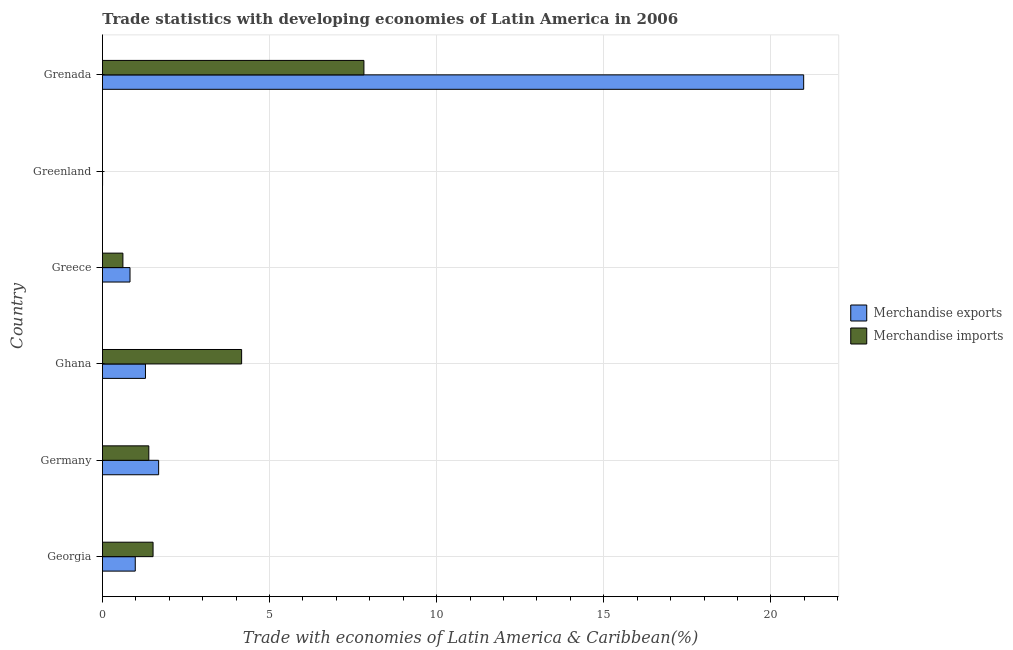How many different coloured bars are there?
Give a very brief answer. 2. How many groups of bars are there?
Make the answer very short. 6. How many bars are there on the 5th tick from the top?
Provide a succinct answer. 2. How many bars are there on the 1st tick from the bottom?
Provide a succinct answer. 2. What is the label of the 4th group of bars from the top?
Give a very brief answer. Ghana. What is the merchandise exports in Greenland?
Your answer should be compact. 0. Across all countries, what is the maximum merchandise imports?
Give a very brief answer. 7.82. Across all countries, what is the minimum merchandise imports?
Offer a terse response. 0. In which country was the merchandise exports maximum?
Ensure brevity in your answer.  Grenada. In which country was the merchandise imports minimum?
Provide a succinct answer. Greenland. What is the total merchandise imports in the graph?
Offer a terse response. 15.5. What is the difference between the merchandise imports in Germany and that in Greenland?
Offer a very short reply. 1.39. What is the difference between the merchandise exports in Grenada and the merchandise imports in Ghana?
Give a very brief answer. 16.82. What is the average merchandise exports per country?
Your answer should be very brief. 4.29. What is the difference between the merchandise exports and merchandise imports in Germany?
Offer a very short reply. 0.29. In how many countries, is the merchandise imports greater than 10 %?
Provide a succinct answer. 0. What is the ratio of the merchandise imports in Georgia to that in Grenada?
Your response must be concise. 0.19. Is the merchandise exports in Germany less than that in Ghana?
Provide a short and direct response. No. Is the difference between the merchandise imports in Georgia and Greenland greater than the difference between the merchandise exports in Georgia and Greenland?
Your response must be concise. Yes. What is the difference between the highest and the second highest merchandise imports?
Offer a terse response. 3.66. What is the difference between the highest and the lowest merchandise imports?
Offer a very short reply. 7.82. In how many countries, is the merchandise exports greater than the average merchandise exports taken over all countries?
Keep it short and to the point. 1. Is the sum of the merchandise imports in Georgia and Grenada greater than the maximum merchandise exports across all countries?
Provide a succinct answer. No. How many bars are there?
Provide a short and direct response. 12. Are all the bars in the graph horizontal?
Your answer should be compact. Yes. What is the difference between two consecutive major ticks on the X-axis?
Keep it short and to the point. 5. Does the graph contain any zero values?
Provide a short and direct response. No. Where does the legend appear in the graph?
Provide a succinct answer. Center right. What is the title of the graph?
Keep it short and to the point. Trade statistics with developing economies of Latin America in 2006. Does "Highest 10% of population" appear as one of the legend labels in the graph?
Make the answer very short. No. What is the label or title of the X-axis?
Make the answer very short. Trade with economies of Latin America & Caribbean(%). What is the Trade with economies of Latin America & Caribbean(%) of Merchandise exports in Georgia?
Provide a succinct answer. 0.98. What is the Trade with economies of Latin America & Caribbean(%) in Merchandise imports in Georgia?
Ensure brevity in your answer.  1.51. What is the Trade with economies of Latin America & Caribbean(%) of Merchandise exports in Germany?
Your answer should be compact. 1.68. What is the Trade with economies of Latin America & Caribbean(%) in Merchandise imports in Germany?
Make the answer very short. 1.39. What is the Trade with economies of Latin America & Caribbean(%) in Merchandise exports in Ghana?
Provide a succinct answer. 1.29. What is the Trade with economies of Latin America & Caribbean(%) of Merchandise imports in Ghana?
Provide a succinct answer. 4.16. What is the Trade with economies of Latin America & Caribbean(%) of Merchandise exports in Greece?
Ensure brevity in your answer.  0.82. What is the Trade with economies of Latin America & Caribbean(%) in Merchandise imports in Greece?
Provide a short and direct response. 0.61. What is the Trade with economies of Latin America & Caribbean(%) in Merchandise exports in Greenland?
Ensure brevity in your answer.  0. What is the Trade with economies of Latin America & Caribbean(%) of Merchandise imports in Greenland?
Make the answer very short. 0. What is the Trade with economies of Latin America & Caribbean(%) in Merchandise exports in Grenada?
Your answer should be compact. 20.98. What is the Trade with economies of Latin America & Caribbean(%) in Merchandise imports in Grenada?
Your answer should be very brief. 7.82. Across all countries, what is the maximum Trade with economies of Latin America & Caribbean(%) of Merchandise exports?
Your response must be concise. 20.98. Across all countries, what is the maximum Trade with economies of Latin America & Caribbean(%) in Merchandise imports?
Your response must be concise. 7.82. Across all countries, what is the minimum Trade with economies of Latin America & Caribbean(%) in Merchandise exports?
Your response must be concise. 0. Across all countries, what is the minimum Trade with economies of Latin America & Caribbean(%) in Merchandise imports?
Offer a very short reply. 0. What is the total Trade with economies of Latin America & Caribbean(%) of Merchandise exports in the graph?
Offer a terse response. 25.76. What is the total Trade with economies of Latin America & Caribbean(%) in Merchandise imports in the graph?
Offer a very short reply. 15.5. What is the difference between the Trade with economies of Latin America & Caribbean(%) of Merchandise exports in Georgia and that in Germany?
Keep it short and to the point. -0.7. What is the difference between the Trade with economies of Latin America & Caribbean(%) in Merchandise imports in Georgia and that in Germany?
Keep it short and to the point. 0.13. What is the difference between the Trade with economies of Latin America & Caribbean(%) of Merchandise exports in Georgia and that in Ghana?
Your answer should be very brief. -0.31. What is the difference between the Trade with economies of Latin America & Caribbean(%) in Merchandise imports in Georgia and that in Ghana?
Ensure brevity in your answer.  -2.65. What is the difference between the Trade with economies of Latin America & Caribbean(%) of Merchandise exports in Georgia and that in Greece?
Ensure brevity in your answer.  0.16. What is the difference between the Trade with economies of Latin America & Caribbean(%) in Merchandise imports in Georgia and that in Greece?
Offer a terse response. 0.9. What is the difference between the Trade with economies of Latin America & Caribbean(%) of Merchandise exports in Georgia and that in Greenland?
Keep it short and to the point. 0.98. What is the difference between the Trade with economies of Latin America & Caribbean(%) of Merchandise imports in Georgia and that in Greenland?
Keep it short and to the point. 1.51. What is the difference between the Trade with economies of Latin America & Caribbean(%) of Merchandise exports in Georgia and that in Grenada?
Offer a terse response. -20. What is the difference between the Trade with economies of Latin America & Caribbean(%) of Merchandise imports in Georgia and that in Grenada?
Offer a very short reply. -6.31. What is the difference between the Trade with economies of Latin America & Caribbean(%) in Merchandise exports in Germany and that in Ghana?
Offer a terse response. 0.39. What is the difference between the Trade with economies of Latin America & Caribbean(%) of Merchandise imports in Germany and that in Ghana?
Ensure brevity in your answer.  -2.78. What is the difference between the Trade with economies of Latin America & Caribbean(%) in Merchandise exports in Germany and that in Greece?
Your answer should be very brief. 0.86. What is the difference between the Trade with economies of Latin America & Caribbean(%) of Merchandise imports in Germany and that in Greece?
Ensure brevity in your answer.  0.78. What is the difference between the Trade with economies of Latin America & Caribbean(%) of Merchandise exports in Germany and that in Greenland?
Give a very brief answer. 1.68. What is the difference between the Trade with economies of Latin America & Caribbean(%) in Merchandise imports in Germany and that in Greenland?
Keep it short and to the point. 1.39. What is the difference between the Trade with economies of Latin America & Caribbean(%) of Merchandise exports in Germany and that in Grenada?
Provide a short and direct response. -19.3. What is the difference between the Trade with economies of Latin America & Caribbean(%) of Merchandise imports in Germany and that in Grenada?
Keep it short and to the point. -6.44. What is the difference between the Trade with economies of Latin America & Caribbean(%) of Merchandise exports in Ghana and that in Greece?
Your answer should be compact. 0.46. What is the difference between the Trade with economies of Latin America & Caribbean(%) in Merchandise imports in Ghana and that in Greece?
Ensure brevity in your answer.  3.55. What is the difference between the Trade with economies of Latin America & Caribbean(%) in Merchandise exports in Ghana and that in Greenland?
Make the answer very short. 1.28. What is the difference between the Trade with economies of Latin America & Caribbean(%) of Merchandise imports in Ghana and that in Greenland?
Offer a terse response. 4.16. What is the difference between the Trade with economies of Latin America & Caribbean(%) in Merchandise exports in Ghana and that in Grenada?
Offer a terse response. -19.69. What is the difference between the Trade with economies of Latin America & Caribbean(%) in Merchandise imports in Ghana and that in Grenada?
Offer a terse response. -3.66. What is the difference between the Trade with economies of Latin America & Caribbean(%) in Merchandise exports in Greece and that in Greenland?
Your response must be concise. 0.82. What is the difference between the Trade with economies of Latin America & Caribbean(%) in Merchandise imports in Greece and that in Greenland?
Make the answer very short. 0.61. What is the difference between the Trade with economies of Latin America & Caribbean(%) in Merchandise exports in Greece and that in Grenada?
Provide a succinct answer. -20.16. What is the difference between the Trade with economies of Latin America & Caribbean(%) in Merchandise imports in Greece and that in Grenada?
Provide a short and direct response. -7.21. What is the difference between the Trade with economies of Latin America & Caribbean(%) of Merchandise exports in Greenland and that in Grenada?
Ensure brevity in your answer.  -20.98. What is the difference between the Trade with economies of Latin America & Caribbean(%) of Merchandise imports in Greenland and that in Grenada?
Provide a short and direct response. -7.82. What is the difference between the Trade with economies of Latin America & Caribbean(%) of Merchandise exports in Georgia and the Trade with economies of Latin America & Caribbean(%) of Merchandise imports in Germany?
Your answer should be compact. -0.41. What is the difference between the Trade with economies of Latin America & Caribbean(%) of Merchandise exports in Georgia and the Trade with economies of Latin America & Caribbean(%) of Merchandise imports in Ghana?
Your response must be concise. -3.18. What is the difference between the Trade with economies of Latin America & Caribbean(%) in Merchandise exports in Georgia and the Trade with economies of Latin America & Caribbean(%) in Merchandise imports in Greece?
Give a very brief answer. 0.37. What is the difference between the Trade with economies of Latin America & Caribbean(%) of Merchandise exports in Georgia and the Trade with economies of Latin America & Caribbean(%) of Merchandise imports in Greenland?
Ensure brevity in your answer.  0.98. What is the difference between the Trade with economies of Latin America & Caribbean(%) of Merchandise exports in Georgia and the Trade with economies of Latin America & Caribbean(%) of Merchandise imports in Grenada?
Keep it short and to the point. -6.84. What is the difference between the Trade with economies of Latin America & Caribbean(%) in Merchandise exports in Germany and the Trade with economies of Latin America & Caribbean(%) in Merchandise imports in Ghana?
Offer a terse response. -2.48. What is the difference between the Trade with economies of Latin America & Caribbean(%) of Merchandise exports in Germany and the Trade with economies of Latin America & Caribbean(%) of Merchandise imports in Greece?
Your answer should be very brief. 1.07. What is the difference between the Trade with economies of Latin America & Caribbean(%) in Merchandise exports in Germany and the Trade with economies of Latin America & Caribbean(%) in Merchandise imports in Greenland?
Your answer should be compact. 1.68. What is the difference between the Trade with economies of Latin America & Caribbean(%) of Merchandise exports in Germany and the Trade with economies of Latin America & Caribbean(%) of Merchandise imports in Grenada?
Make the answer very short. -6.14. What is the difference between the Trade with economies of Latin America & Caribbean(%) of Merchandise exports in Ghana and the Trade with economies of Latin America & Caribbean(%) of Merchandise imports in Greece?
Your answer should be very brief. 0.68. What is the difference between the Trade with economies of Latin America & Caribbean(%) in Merchandise exports in Ghana and the Trade with economies of Latin America & Caribbean(%) in Merchandise imports in Greenland?
Your answer should be very brief. 1.29. What is the difference between the Trade with economies of Latin America & Caribbean(%) in Merchandise exports in Ghana and the Trade with economies of Latin America & Caribbean(%) in Merchandise imports in Grenada?
Provide a short and direct response. -6.54. What is the difference between the Trade with economies of Latin America & Caribbean(%) of Merchandise exports in Greece and the Trade with economies of Latin America & Caribbean(%) of Merchandise imports in Greenland?
Offer a very short reply. 0.82. What is the difference between the Trade with economies of Latin America & Caribbean(%) in Merchandise exports in Greece and the Trade with economies of Latin America & Caribbean(%) in Merchandise imports in Grenada?
Offer a very short reply. -7. What is the difference between the Trade with economies of Latin America & Caribbean(%) in Merchandise exports in Greenland and the Trade with economies of Latin America & Caribbean(%) in Merchandise imports in Grenada?
Provide a short and direct response. -7.82. What is the average Trade with economies of Latin America & Caribbean(%) in Merchandise exports per country?
Offer a very short reply. 4.29. What is the average Trade with economies of Latin America & Caribbean(%) in Merchandise imports per country?
Provide a short and direct response. 2.58. What is the difference between the Trade with economies of Latin America & Caribbean(%) of Merchandise exports and Trade with economies of Latin America & Caribbean(%) of Merchandise imports in Georgia?
Your answer should be compact. -0.53. What is the difference between the Trade with economies of Latin America & Caribbean(%) in Merchandise exports and Trade with economies of Latin America & Caribbean(%) in Merchandise imports in Germany?
Your response must be concise. 0.29. What is the difference between the Trade with economies of Latin America & Caribbean(%) of Merchandise exports and Trade with economies of Latin America & Caribbean(%) of Merchandise imports in Ghana?
Provide a succinct answer. -2.88. What is the difference between the Trade with economies of Latin America & Caribbean(%) in Merchandise exports and Trade with economies of Latin America & Caribbean(%) in Merchandise imports in Greece?
Keep it short and to the point. 0.21. What is the difference between the Trade with economies of Latin America & Caribbean(%) of Merchandise exports and Trade with economies of Latin America & Caribbean(%) of Merchandise imports in Greenland?
Offer a very short reply. 0. What is the difference between the Trade with economies of Latin America & Caribbean(%) of Merchandise exports and Trade with economies of Latin America & Caribbean(%) of Merchandise imports in Grenada?
Your answer should be very brief. 13.16. What is the ratio of the Trade with economies of Latin America & Caribbean(%) in Merchandise exports in Georgia to that in Germany?
Keep it short and to the point. 0.58. What is the ratio of the Trade with economies of Latin America & Caribbean(%) of Merchandise imports in Georgia to that in Germany?
Provide a short and direct response. 1.09. What is the ratio of the Trade with economies of Latin America & Caribbean(%) in Merchandise exports in Georgia to that in Ghana?
Give a very brief answer. 0.76. What is the ratio of the Trade with economies of Latin America & Caribbean(%) of Merchandise imports in Georgia to that in Ghana?
Offer a terse response. 0.36. What is the ratio of the Trade with economies of Latin America & Caribbean(%) of Merchandise exports in Georgia to that in Greece?
Your answer should be compact. 1.19. What is the ratio of the Trade with economies of Latin America & Caribbean(%) of Merchandise imports in Georgia to that in Greece?
Keep it short and to the point. 2.47. What is the ratio of the Trade with economies of Latin America & Caribbean(%) in Merchandise exports in Georgia to that in Greenland?
Offer a terse response. 293.79. What is the ratio of the Trade with economies of Latin America & Caribbean(%) in Merchandise imports in Georgia to that in Greenland?
Your answer should be compact. 1747.71. What is the ratio of the Trade with economies of Latin America & Caribbean(%) of Merchandise exports in Georgia to that in Grenada?
Offer a very short reply. 0.05. What is the ratio of the Trade with economies of Latin America & Caribbean(%) of Merchandise imports in Georgia to that in Grenada?
Your response must be concise. 0.19. What is the ratio of the Trade with economies of Latin America & Caribbean(%) of Merchandise exports in Germany to that in Ghana?
Give a very brief answer. 1.31. What is the ratio of the Trade with economies of Latin America & Caribbean(%) in Merchandise imports in Germany to that in Ghana?
Provide a succinct answer. 0.33. What is the ratio of the Trade with economies of Latin America & Caribbean(%) of Merchandise exports in Germany to that in Greece?
Ensure brevity in your answer.  2.04. What is the ratio of the Trade with economies of Latin America & Caribbean(%) of Merchandise imports in Germany to that in Greece?
Ensure brevity in your answer.  2.27. What is the ratio of the Trade with economies of Latin America & Caribbean(%) in Merchandise exports in Germany to that in Greenland?
Keep it short and to the point. 503.02. What is the ratio of the Trade with economies of Latin America & Caribbean(%) in Merchandise imports in Germany to that in Greenland?
Keep it short and to the point. 1601.11. What is the ratio of the Trade with economies of Latin America & Caribbean(%) of Merchandise exports in Germany to that in Grenada?
Provide a succinct answer. 0.08. What is the ratio of the Trade with economies of Latin America & Caribbean(%) of Merchandise imports in Germany to that in Grenada?
Provide a succinct answer. 0.18. What is the ratio of the Trade with economies of Latin America & Caribbean(%) of Merchandise exports in Ghana to that in Greece?
Keep it short and to the point. 1.56. What is the ratio of the Trade with economies of Latin America & Caribbean(%) of Merchandise imports in Ghana to that in Greece?
Give a very brief answer. 6.8. What is the ratio of the Trade with economies of Latin America & Caribbean(%) of Merchandise exports in Ghana to that in Greenland?
Ensure brevity in your answer.  385.13. What is the ratio of the Trade with economies of Latin America & Caribbean(%) of Merchandise imports in Ghana to that in Greenland?
Your answer should be compact. 4805.78. What is the ratio of the Trade with economies of Latin America & Caribbean(%) of Merchandise exports in Ghana to that in Grenada?
Ensure brevity in your answer.  0.06. What is the ratio of the Trade with economies of Latin America & Caribbean(%) in Merchandise imports in Ghana to that in Grenada?
Provide a short and direct response. 0.53. What is the ratio of the Trade with economies of Latin America & Caribbean(%) in Merchandise exports in Greece to that in Greenland?
Provide a succinct answer. 246.74. What is the ratio of the Trade with economies of Latin America & Caribbean(%) of Merchandise imports in Greece to that in Greenland?
Ensure brevity in your answer.  706.37. What is the ratio of the Trade with economies of Latin America & Caribbean(%) of Merchandise exports in Greece to that in Grenada?
Offer a terse response. 0.04. What is the ratio of the Trade with economies of Latin America & Caribbean(%) in Merchandise imports in Greece to that in Grenada?
Provide a succinct answer. 0.08. What is the ratio of the Trade with economies of Latin America & Caribbean(%) in Merchandise exports in Greenland to that in Grenada?
Offer a very short reply. 0. What is the ratio of the Trade with economies of Latin America & Caribbean(%) in Merchandise imports in Greenland to that in Grenada?
Offer a terse response. 0. What is the difference between the highest and the second highest Trade with economies of Latin America & Caribbean(%) in Merchandise exports?
Give a very brief answer. 19.3. What is the difference between the highest and the second highest Trade with economies of Latin America & Caribbean(%) of Merchandise imports?
Your answer should be very brief. 3.66. What is the difference between the highest and the lowest Trade with economies of Latin America & Caribbean(%) in Merchandise exports?
Provide a short and direct response. 20.98. What is the difference between the highest and the lowest Trade with economies of Latin America & Caribbean(%) of Merchandise imports?
Keep it short and to the point. 7.82. 